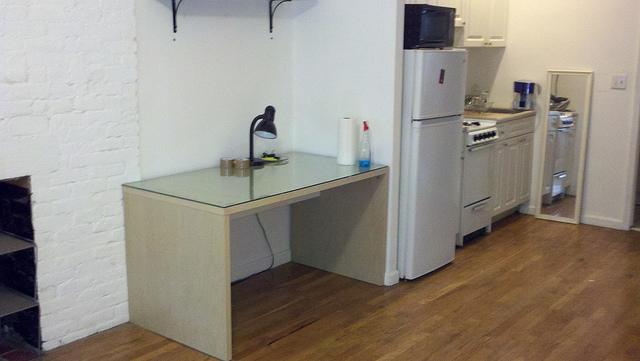What object is out of place in the kitchen? Please explain your reasoning. mirror. The mirror is out of place. 